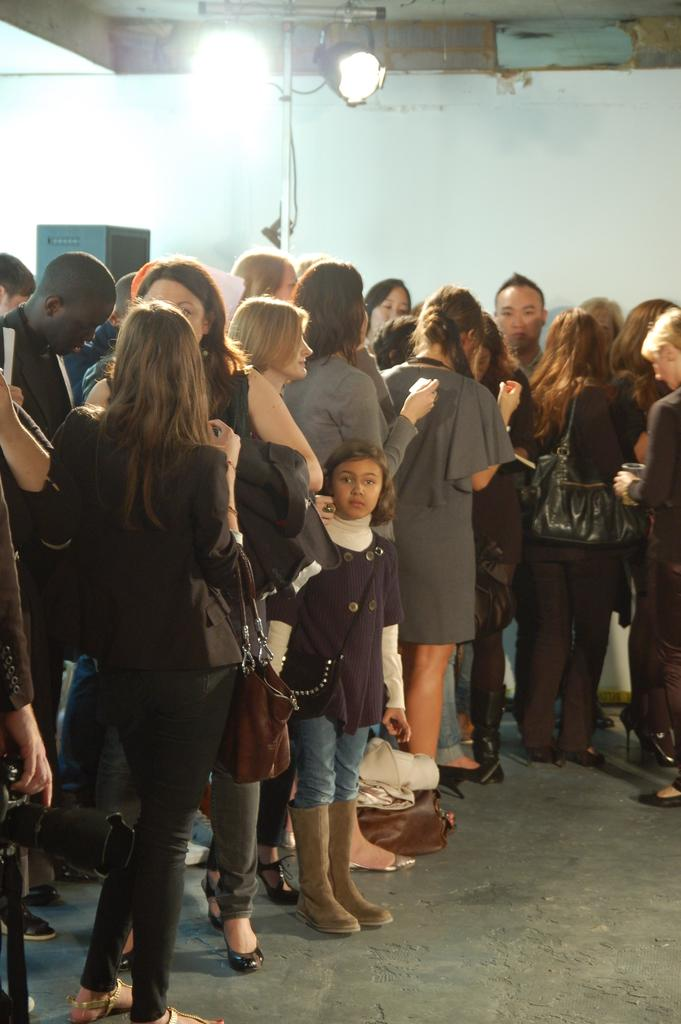Who or what can be seen in the image? There are people in the image. What objects are visible in the image besides the people? There are bags and a wall visible in the image. What type of illumination is present in the image? There are lights in the image. How are some people using the bags in the image? Some people are wearing bags in the image. What type of sidewalk can be seen in the image? There is no sidewalk present in the image. What kind of brush is being used by the people in the image? There is no brush visible in the image. 